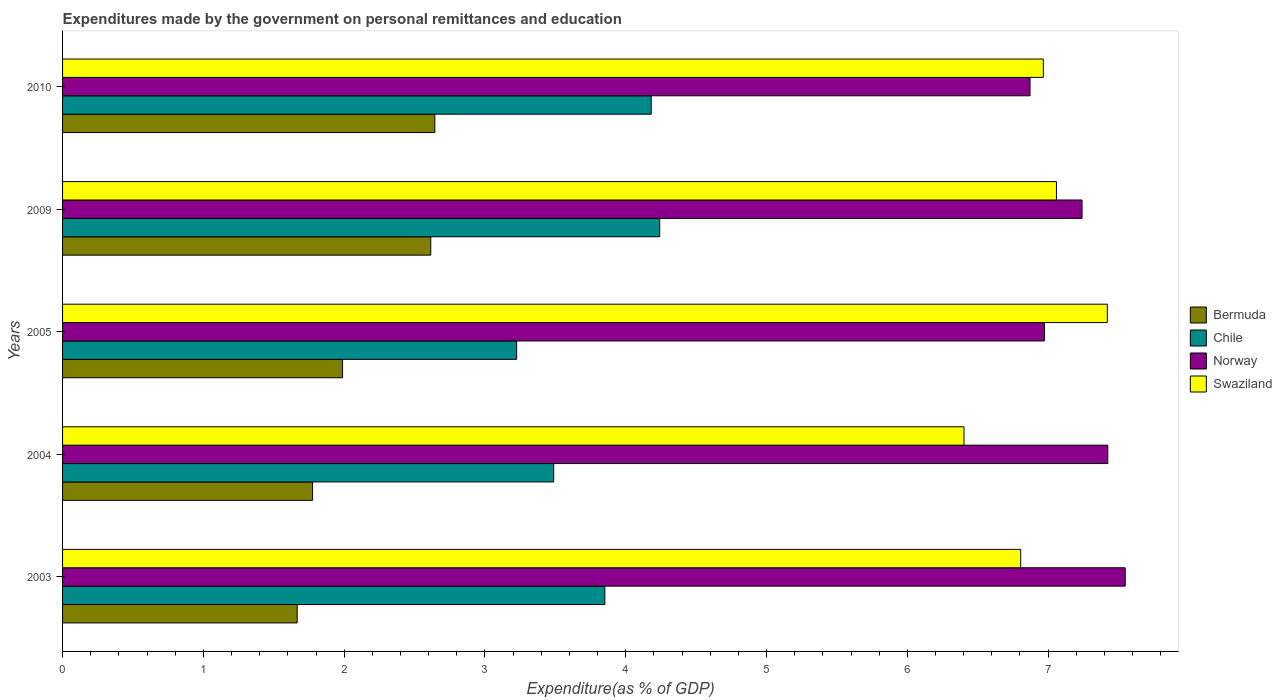How many different coloured bars are there?
Offer a terse response. 4. Are the number of bars on each tick of the Y-axis equal?
Give a very brief answer. Yes. What is the expenditures made by the government on personal remittances and education in Swaziland in 2004?
Your answer should be very brief. 6.4. Across all years, what is the maximum expenditures made by the government on personal remittances and education in Swaziland?
Ensure brevity in your answer.  7.42. Across all years, what is the minimum expenditures made by the government on personal remittances and education in Chile?
Provide a short and direct response. 3.23. In which year was the expenditures made by the government on personal remittances and education in Bermuda maximum?
Make the answer very short. 2010. What is the total expenditures made by the government on personal remittances and education in Norway in the graph?
Offer a terse response. 36.06. What is the difference between the expenditures made by the government on personal remittances and education in Bermuda in 2004 and that in 2005?
Give a very brief answer. -0.21. What is the difference between the expenditures made by the government on personal remittances and education in Swaziland in 2004 and the expenditures made by the government on personal remittances and education in Chile in 2003?
Provide a short and direct response. 2.55. What is the average expenditures made by the government on personal remittances and education in Swaziland per year?
Make the answer very short. 6.93. In the year 2005, what is the difference between the expenditures made by the government on personal remittances and education in Chile and expenditures made by the government on personal remittances and education in Swaziland?
Make the answer very short. -4.2. What is the ratio of the expenditures made by the government on personal remittances and education in Norway in 2004 to that in 2010?
Offer a terse response. 1.08. What is the difference between the highest and the second highest expenditures made by the government on personal remittances and education in Chile?
Keep it short and to the point. 0.06. What is the difference between the highest and the lowest expenditures made by the government on personal remittances and education in Norway?
Your answer should be very brief. 0.68. In how many years, is the expenditures made by the government on personal remittances and education in Chile greater than the average expenditures made by the government on personal remittances and education in Chile taken over all years?
Ensure brevity in your answer.  3. Is it the case that in every year, the sum of the expenditures made by the government on personal remittances and education in Norway and expenditures made by the government on personal remittances and education in Bermuda is greater than the sum of expenditures made by the government on personal remittances and education in Swaziland and expenditures made by the government on personal remittances and education in Chile?
Your response must be concise. No. What does the 4th bar from the top in 2009 represents?
Your response must be concise. Bermuda. Are all the bars in the graph horizontal?
Your answer should be compact. Yes. Are the values on the major ticks of X-axis written in scientific E-notation?
Provide a short and direct response. No. Does the graph contain any zero values?
Offer a terse response. No. How many legend labels are there?
Your response must be concise. 4. What is the title of the graph?
Give a very brief answer. Expenditures made by the government on personal remittances and education. Does "St. Martin (French part)" appear as one of the legend labels in the graph?
Your response must be concise. No. What is the label or title of the X-axis?
Make the answer very short. Expenditure(as % of GDP). What is the Expenditure(as % of GDP) in Bermuda in 2003?
Make the answer very short. 1.67. What is the Expenditure(as % of GDP) in Chile in 2003?
Ensure brevity in your answer.  3.85. What is the Expenditure(as % of GDP) of Norway in 2003?
Provide a short and direct response. 7.55. What is the Expenditure(as % of GDP) of Swaziland in 2003?
Ensure brevity in your answer.  6.81. What is the Expenditure(as % of GDP) of Bermuda in 2004?
Provide a succinct answer. 1.78. What is the Expenditure(as % of GDP) of Chile in 2004?
Give a very brief answer. 3.49. What is the Expenditure(as % of GDP) of Norway in 2004?
Give a very brief answer. 7.42. What is the Expenditure(as % of GDP) in Swaziland in 2004?
Keep it short and to the point. 6.4. What is the Expenditure(as % of GDP) of Bermuda in 2005?
Your answer should be compact. 1.99. What is the Expenditure(as % of GDP) of Chile in 2005?
Give a very brief answer. 3.23. What is the Expenditure(as % of GDP) in Norway in 2005?
Offer a very short reply. 6.97. What is the Expenditure(as % of GDP) of Swaziland in 2005?
Your answer should be compact. 7.42. What is the Expenditure(as % of GDP) in Bermuda in 2009?
Offer a very short reply. 2.62. What is the Expenditure(as % of GDP) in Chile in 2009?
Keep it short and to the point. 4.24. What is the Expenditure(as % of GDP) of Norway in 2009?
Your response must be concise. 7.24. What is the Expenditure(as % of GDP) in Swaziland in 2009?
Your response must be concise. 7.06. What is the Expenditure(as % of GDP) of Bermuda in 2010?
Ensure brevity in your answer.  2.64. What is the Expenditure(as % of GDP) of Chile in 2010?
Give a very brief answer. 4.18. What is the Expenditure(as % of GDP) of Norway in 2010?
Ensure brevity in your answer.  6.87. What is the Expenditure(as % of GDP) of Swaziland in 2010?
Provide a succinct answer. 6.97. Across all years, what is the maximum Expenditure(as % of GDP) in Bermuda?
Ensure brevity in your answer.  2.64. Across all years, what is the maximum Expenditure(as % of GDP) in Chile?
Keep it short and to the point. 4.24. Across all years, what is the maximum Expenditure(as % of GDP) in Norway?
Provide a short and direct response. 7.55. Across all years, what is the maximum Expenditure(as % of GDP) in Swaziland?
Your answer should be compact. 7.42. Across all years, what is the minimum Expenditure(as % of GDP) in Bermuda?
Your answer should be very brief. 1.67. Across all years, what is the minimum Expenditure(as % of GDP) in Chile?
Give a very brief answer. 3.23. Across all years, what is the minimum Expenditure(as % of GDP) in Norway?
Your answer should be compact. 6.87. Across all years, what is the minimum Expenditure(as % of GDP) in Swaziland?
Keep it short and to the point. 6.4. What is the total Expenditure(as % of GDP) of Bermuda in the graph?
Ensure brevity in your answer.  10.69. What is the total Expenditure(as % of GDP) of Chile in the graph?
Give a very brief answer. 18.99. What is the total Expenditure(as % of GDP) in Norway in the graph?
Your response must be concise. 36.06. What is the total Expenditure(as % of GDP) in Swaziland in the graph?
Make the answer very short. 34.65. What is the difference between the Expenditure(as % of GDP) of Bermuda in 2003 and that in 2004?
Offer a terse response. -0.11. What is the difference between the Expenditure(as % of GDP) in Chile in 2003 and that in 2004?
Offer a very short reply. 0.36. What is the difference between the Expenditure(as % of GDP) of Norway in 2003 and that in 2004?
Your answer should be very brief. 0.12. What is the difference between the Expenditure(as % of GDP) in Swaziland in 2003 and that in 2004?
Your answer should be compact. 0.4. What is the difference between the Expenditure(as % of GDP) in Bermuda in 2003 and that in 2005?
Make the answer very short. -0.32. What is the difference between the Expenditure(as % of GDP) in Chile in 2003 and that in 2005?
Offer a terse response. 0.63. What is the difference between the Expenditure(as % of GDP) in Norway in 2003 and that in 2005?
Make the answer very short. 0.57. What is the difference between the Expenditure(as % of GDP) of Swaziland in 2003 and that in 2005?
Provide a short and direct response. -0.62. What is the difference between the Expenditure(as % of GDP) of Bermuda in 2003 and that in 2009?
Provide a short and direct response. -0.95. What is the difference between the Expenditure(as % of GDP) in Chile in 2003 and that in 2009?
Your answer should be compact. -0.39. What is the difference between the Expenditure(as % of GDP) in Norway in 2003 and that in 2009?
Offer a terse response. 0.31. What is the difference between the Expenditure(as % of GDP) in Swaziland in 2003 and that in 2009?
Ensure brevity in your answer.  -0.25. What is the difference between the Expenditure(as % of GDP) of Bermuda in 2003 and that in 2010?
Give a very brief answer. -0.98. What is the difference between the Expenditure(as % of GDP) of Chile in 2003 and that in 2010?
Ensure brevity in your answer.  -0.33. What is the difference between the Expenditure(as % of GDP) of Norway in 2003 and that in 2010?
Keep it short and to the point. 0.68. What is the difference between the Expenditure(as % of GDP) of Swaziland in 2003 and that in 2010?
Provide a short and direct response. -0.16. What is the difference between the Expenditure(as % of GDP) of Bermuda in 2004 and that in 2005?
Give a very brief answer. -0.21. What is the difference between the Expenditure(as % of GDP) in Chile in 2004 and that in 2005?
Provide a succinct answer. 0.26. What is the difference between the Expenditure(as % of GDP) of Norway in 2004 and that in 2005?
Ensure brevity in your answer.  0.45. What is the difference between the Expenditure(as % of GDP) in Swaziland in 2004 and that in 2005?
Provide a succinct answer. -1.02. What is the difference between the Expenditure(as % of GDP) of Bermuda in 2004 and that in 2009?
Your response must be concise. -0.84. What is the difference between the Expenditure(as % of GDP) in Chile in 2004 and that in 2009?
Ensure brevity in your answer.  -0.75. What is the difference between the Expenditure(as % of GDP) in Norway in 2004 and that in 2009?
Provide a succinct answer. 0.18. What is the difference between the Expenditure(as % of GDP) in Swaziland in 2004 and that in 2009?
Give a very brief answer. -0.66. What is the difference between the Expenditure(as % of GDP) in Bermuda in 2004 and that in 2010?
Ensure brevity in your answer.  -0.87. What is the difference between the Expenditure(as % of GDP) of Chile in 2004 and that in 2010?
Make the answer very short. -0.69. What is the difference between the Expenditure(as % of GDP) of Norway in 2004 and that in 2010?
Keep it short and to the point. 0.55. What is the difference between the Expenditure(as % of GDP) of Swaziland in 2004 and that in 2010?
Keep it short and to the point. -0.56. What is the difference between the Expenditure(as % of GDP) of Bermuda in 2005 and that in 2009?
Your response must be concise. -0.63. What is the difference between the Expenditure(as % of GDP) of Chile in 2005 and that in 2009?
Provide a short and direct response. -1.02. What is the difference between the Expenditure(as % of GDP) of Norway in 2005 and that in 2009?
Provide a succinct answer. -0.27. What is the difference between the Expenditure(as % of GDP) of Swaziland in 2005 and that in 2009?
Your answer should be very brief. 0.36. What is the difference between the Expenditure(as % of GDP) in Bermuda in 2005 and that in 2010?
Offer a terse response. -0.66. What is the difference between the Expenditure(as % of GDP) of Chile in 2005 and that in 2010?
Provide a short and direct response. -0.96. What is the difference between the Expenditure(as % of GDP) in Norway in 2005 and that in 2010?
Your response must be concise. 0.1. What is the difference between the Expenditure(as % of GDP) in Swaziland in 2005 and that in 2010?
Your response must be concise. 0.45. What is the difference between the Expenditure(as % of GDP) in Bermuda in 2009 and that in 2010?
Provide a succinct answer. -0.03. What is the difference between the Expenditure(as % of GDP) in Chile in 2009 and that in 2010?
Offer a terse response. 0.06. What is the difference between the Expenditure(as % of GDP) in Norway in 2009 and that in 2010?
Keep it short and to the point. 0.37. What is the difference between the Expenditure(as % of GDP) of Swaziland in 2009 and that in 2010?
Make the answer very short. 0.09. What is the difference between the Expenditure(as % of GDP) in Bermuda in 2003 and the Expenditure(as % of GDP) in Chile in 2004?
Keep it short and to the point. -1.82. What is the difference between the Expenditure(as % of GDP) of Bermuda in 2003 and the Expenditure(as % of GDP) of Norway in 2004?
Your answer should be very brief. -5.76. What is the difference between the Expenditure(as % of GDP) in Bermuda in 2003 and the Expenditure(as % of GDP) in Swaziland in 2004?
Keep it short and to the point. -4.74. What is the difference between the Expenditure(as % of GDP) in Chile in 2003 and the Expenditure(as % of GDP) in Norway in 2004?
Give a very brief answer. -3.57. What is the difference between the Expenditure(as % of GDP) in Chile in 2003 and the Expenditure(as % of GDP) in Swaziland in 2004?
Offer a very short reply. -2.55. What is the difference between the Expenditure(as % of GDP) of Norway in 2003 and the Expenditure(as % of GDP) of Swaziland in 2004?
Your answer should be very brief. 1.14. What is the difference between the Expenditure(as % of GDP) in Bermuda in 2003 and the Expenditure(as % of GDP) in Chile in 2005?
Make the answer very short. -1.56. What is the difference between the Expenditure(as % of GDP) in Bermuda in 2003 and the Expenditure(as % of GDP) in Norway in 2005?
Your answer should be very brief. -5.31. What is the difference between the Expenditure(as % of GDP) of Bermuda in 2003 and the Expenditure(as % of GDP) of Swaziland in 2005?
Provide a short and direct response. -5.75. What is the difference between the Expenditure(as % of GDP) of Chile in 2003 and the Expenditure(as % of GDP) of Norway in 2005?
Provide a short and direct response. -3.12. What is the difference between the Expenditure(as % of GDP) in Chile in 2003 and the Expenditure(as % of GDP) in Swaziland in 2005?
Your response must be concise. -3.57. What is the difference between the Expenditure(as % of GDP) in Norway in 2003 and the Expenditure(as % of GDP) in Swaziland in 2005?
Offer a very short reply. 0.13. What is the difference between the Expenditure(as % of GDP) of Bermuda in 2003 and the Expenditure(as % of GDP) of Chile in 2009?
Keep it short and to the point. -2.58. What is the difference between the Expenditure(as % of GDP) of Bermuda in 2003 and the Expenditure(as % of GDP) of Norway in 2009?
Ensure brevity in your answer.  -5.57. What is the difference between the Expenditure(as % of GDP) in Bermuda in 2003 and the Expenditure(as % of GDP) in Swaziland in 2009?
Your answer should be compact. -5.39. What is the difference between the Expenditure(as % of GDP) of Chile in 2003 and the Expenditure(as % of GDP) of Norway in 2009?
Offer a very short reply. -3.39. What is the difference between the Expenditure(as % of GDP) in Chile in 2003 and the Expenditure(as % of GDP) in Swaziland in 2009?
Your answer should be compact. -3.21. What is the difference between the Expenditure(as % of GDP) of Norway in 2003 and the Expenditure(as % of GDP) of Swaziland in 2009?
Offer a terse response. 0.49. What is the difference between the Expenditure(as % of GDP) in Bermuda in 2003 and the Expenditure(as % of GDP) in Chile in 2010?
Your response must be concise. -2.51. What is the difference between the Expenditure(as % of GDP) of Bermuda in 2003 and the Expenditure(as % of GDP) of Norway in 2010?
Keep it short and to the point. -5.21. What is the difference between the Expenditure(as % of GDP) of Bermuda in 2003 and the Expenditure(as % of GDP) of Swaziland in 2010?
Provide a succinct answer. -5.3. What is the difference between the Expenditure(as % of GDP) of Chile in 2003 and the Expenditure(as % of GDP) of Norway in 2010?
Your answer should be very brief. -3.02. What is the difference between the Expenditure(as % of GDP) of Chile in 2003 and the Expenditure(as % of GDP) of Swaziland in 2010?
Provide a short and direct response. -3.11. What is the difference between the Expenditure(as % of GDP) in Norway in 2003 and the Expenditure(as % of GDP) in Swaziland in 2010?
Offer a very short reply. 0.58. What is the difference between the Expenditure(as % of GDP) of Bermuda in 2004 and the Expenditure(as % of GDP) of Chile in 2005?
Make the answer very short. -1.45. What is the difference between the Expenditure(as % of GDP) in Bermuda in 2004 and the Expenditure(as % of GDP) in Norway in 2005?
Provide a short and direct response. -5.2. What is the difference between the Expenditure(as % of GDP) in Bermuda in 2004 and the Expenditure(as % of GDP) in Swaziland in 2005?
Your answer should be very brief. -5.64. What is the difference between the Expenditure(as % of GDP) in Chile in 2004 and the Expenditure(as % of GDP) in Norway in 2005?
Provide a short and direct response. -3.49. What is the difference between the Expenditure(as % of GDP) of Chile in 2004 and the Expenditure(as % of GDP) of Swaziland in 2005?
Offer a terse response. -3.93. What is the difference between the Expenditure(as % of GDP) of Norway in 2004 and the Expenditure(as % of GDP) of Swaziland in 2005?
Offer a very short reply. 0. What is the difference between the Expenditure(as % of GDP) in Bermuda in 2004 and the Expenditure(as % of GDP) in Chile in 2009?
Your answer should be compact. -2.47. What is the difference between the Expenditure(as % of GDP) in Bermuda in 2004 and the Expenditure(as % of GDP) in Norway in 2009?
Your answer should be very brief. -5.47. What is the difference between the Expenditure(as % of GDP) in Bermuda in 2004 and the Expenditure(as % of GDP) in Swaziland in 2009?
Keep it short and to the point. -5.28. What is the difference between the Expenditure(as % of GDP) in Chile in 2004 and the Expenditure(as % of GDP) in Norway in 2009?
Your answer should be very brief. -3.75. What is the difference between the Expenditure(as % of GDP) in Chile in 2004 and the Expenditure(as % of GDP) in Swaziland in 2009?
Provide a short and direct response. -3.57. What is the difference between the Expenditure(as % of GDP) in Norway in 2004 and the Expenditure(as % of GDP) in Swaziland in 2009?
Provide a short and direct response. 0.36. What is the difference between the Expenditure(as % of GDP) of Bermuda in 2004 and the Expenditure(as % of GDP) of Chile in 2010?
Ensure brevity in your answer.  -2.4. What is the difference between the Expenditure(as % of GDP) in Bermuda in 2004 and the Expenditure(as % of GDP) in Norway in 2010?
Your response must be concise. -5.1. What is the difference between the Expenditure(as % of GDP) in Bermuda in 2004 and the Expenditure(as % of GDP) in Swaziland in 2010?
Your answer should be compact. -5.19. What is the difference between the Expenditure(as % of GDP) of Chile in 2004 and the Expenditure(as % of GDP) of Norway in 2010?
Provide a short and direct response. -3.38. What is the difference between the Expenditure(as % of GDP) in Chile in 2004 and the Expenditure(as % of GDP) in Swaziland in 2010?
Offer a terse response. -3.48. What is the difference between the Expenditure(as % of GDP) of Norway in 2004 and the Expenditure(as % of GDP) of Swaziland in 2010?
Provide a succinct answer. 0.46. What is the difference between the Expenditure(as % of GDP) of Bermuda in 2005 and the Expenditure(as % of GDP) of Chile in 2009?
Provide a short and direct response. -2.25. What is the difference between the Expenditure(as % of GDP) in Bermuda in 2005 and the Expenditure(as % of GDP) in Norway in 2009?
Ensure brevity in your answer.  -5.25. What is the difference between the Expenditure(as % of GDP) in Bermuda in 2005 and the Expenditure(as % of GDP) in Swaziland in 2009?
Your answer should be compact. -5.07. What is the difference between the Expenditure(as % of GDP) in Chile in 2005 and the Expenditure(as % of GDP) in Norway in 2009?
Your answer should be compact. -4.02. What is the difference between the Expenditure(as % of GDP) in Chile in 2005 and the Expenditure(as % of GDP) in Swaziland in 2009?
Your answer should be very brief. -3.83. What is the difference between the Expenditure(as % of GDP) in Norway in 2005 and the Expenditure(as % of GDP) in Swaziland in 2009?
Offer a very short reply. -0.09. What is the difference between the Expenditure(as % of GDP) of Bermuda in 2005 and the Expenditure(as % of GDP) of Chile in 2010?
Your answer should be compact. -2.19. What is the difference between the Expenditure(as % of GDP) of Bermuda in 2005 and the Expenditure(as % of GDP) of Norway in 2010?
Your answer should be compact. -4.88. What is the difference between the Expenditure(as % of GDP) of Bermuda in 2005 and the Expenditure(as % of GDP) of Swaziland in 2010?
Offer a terse response. -4.98. What is the difference between the Expenditure(as % of GDP) in Chile in 2005 and the Expenditure(as % of GDP) in Norway in 2010?
Provide a short and direct response. -3.65. What is the difference between the Expenditure(as % of GDP) in Chile in 2005 and the Expenditure(as % of GDP) in Swaziland in 2010?
Offer a terse response. -3.74. What is the difference between the Expenditure(as % of GDP) in Norway in 2005 and the Expenditure(as % of GDP) in Swaziland in 2010?
Provide a short and direct response. 0.01. What is the difference between the Expenditure(as % of GDP) in Bermuda in 2009 and the Expenditure(as % of GDP) in Chile in 2010?
Provide a succinct answer. -1.57. What is the difference between the Expenditure(as % of GDP) of Bermuda in 2009 and the Expenditure(as % of GDP) of Norway in 2010?
Make the answer very short. -4.26. What is the difference between the Expenditure(as % of GDP) of Bermuda in 2009 and the Expenditure(as % of GDP) of Swaziland in 2010?
Make the answer very short. -4.35. What is the difference between the Expenditure(as % of GDP) of Chile in 2009 and the Expenditure(as % of GDP) of Norway in 2010?
Keep it short and to the point. -2.63. What is the difference between the Expenditure(as % of GDP) in Chile in 2009 and the Expenditure(as % of GDP) in Swaziland in 2010?
Give a very brief answer. -2.72. What is the difference between the Expenditure(as % of GDP) in Norway in 2009 and the Expenditure(as % of GDP) in Swaziland in 2010?
Keep it short and to the point. 0.27. What is the average Expenditure(as % of GDP) in Bermuda per year?
Provide a succinct answer. 2.14. What is the average Expenditure(as % of GDP) of Chile per year?
Offer a terse response. 3.8. What is the average Expenditure(as % of GDP) in Norway per year?
Offer a very short reply. 7.21. What is the average Expenditure(as % of GDP) of Swaziland per year?
Provide a short and direct response. 6.93. In the year 2003, what is the difference between the Expenditure(as % of GDP) in Bermuda and Expenditure(as % of GDP) in Chile?
Offer a terse response. -2.19. In the year 2003, what is the difference between the Expenditure(as % of GDP) in Bermuda and Expenditure(as % of GDP) in Norway?
Give a very brief answer. -5.88. In the year 2003, what is the difference between the Expenditure(as % of GDP) of Bermuda and Expenditure(as % of GDP) of Swaziland?
Keep it short and to the point. -5.14. In the year 2003, what is the difference between the Expenditure(as % of GDP) of Chile and Expenditure(as % of GDP) of Norway?
Your answer should be very brief. -3.7. In the year 2003, what is the difference between the Expenditure(as % of GDP) of Chile and Expenditure(as % of GDP) of Swaziland?
Give a very brief answer. -2.95. In the year 2003, what is the difference between the Expenditure(as % of GDP) of Norway and Expenditure(as % of GDP) of Swaziland?
Provide a succinct answer. 0.74. In the year 2004, what is the difference between the Expenditure(as % of GDP) in Bermuda and Expenditure(as % of GDP) in Chile?
Provide a succinct answer. -1.71. In the year 2004, what is the difference between the Expenditure(as % of GDP) in Bermuda and Expenditure(as % of GDP) in Norway?
Give a very brief answer. -5.65. In the year 2004, what is the difference between the Expenditure(as % of GDP) of Bermuda and Expenditure(as % of GDP) of Swaziland?
Provide a succinct answer. -4.63. In the year 2004, what is the difference between the Expenditure(as % of GDP) in Chile and Expenditure(as % of GDP) in Norway?
Ensure brevity in your answer.  -3.94. In the year 2004, what is the difference between the Expenditure(as % of GDP) of Chile and Expenditure(as % of GDP) of Swaziland?
Offer a terse response. -2.91. In the year 2004, what is the difference between the Expenditure(as % of GDP) in Norway and Expenditure(as % of GDP) in Swaziland?
Provide a short and direct response. 1.02. In the year 2005, what is the difference between the Expenditure(as % of GDP) in Bermuda and Expenditure(as % of GDP) in Chile?
Your response must be concise. -1.24. In the year 2005, what is the difference between the Expenditure(as % of GDP) in Bermuda and Expenditure(as % of GDP) in Norway?
Keep it short and to the point. -4.99. In the year 2005, what is the difference between the Expenditure(as % of GDP) of Bermuda and Expenditure(as % of GDP) of Swaziland?
Keep it short and to the point. -5.43. In the year 2005, what is the difference between the Expenditure(as % of GDP) of Chile and Expenditure(as % of GDP) of Norway?
Provide a short and direct response. -3.75. In the year 2005, what is the difference between the Expenditure(as % of GDP) in Chile and Expenditure(as % of GDP) in Swaziland?
Offer a terse response. -4.2. In the year 2005, what is the difference between the Expenditure(as % of GDP) of Norway and Expenditure(as % of GDP) of Swaziland?
Give a very brief answer. -0.45. In the year 2009, what is the difference between the Expenditure(as % of GDP) of Bermuda and Expenditure(as % of GDP) of Chile?
Keep it short and to the point. -1.63. In the year 2009, what is the difference between the Expenditure(as % of GDP) of Bermuda and Expenditure(as % of GDP) of Norway?
Provide a succinct answer. -4.63. In the year 2009, what is the difference between the Expenditure(as % of GDP) in Bermuda and Expenditure(as % of GDP) in Swaziland?
Ensure brevity in your answer.  -4.44. In the year 2009, what is the difference between the Expenditure(as % of GDP) in Chile and Expenditure(as % of GDP) in Norway?
Your answer should be very brief. -3. In the year 2009, what is the difference between the Expenditure(as % of GDP) in Chile and Expenditure(as % of GDP) in Swaziland?
Your response must be concise. -2.82. In the year 2009, what is the difference between the Expenditure(as % of GDP) of Norway and Expenditure(as % of GDP) of Swaziland?
Ensure brevity in your answer.  0.18. In the year 2010, what is the difference between the Expenditure(as % of GDP) of Bermuda and Expenditure(as % of GDP) of Chile?
Offer a terse response. -1.54. In the year 2010, what is the difference between the Expenditure(as % of GDP) of Bermuda and Expenditure(as % of GDP) of Norway?
Keep it short and to the point. -4.23. In the year 2010, what is the difference between the Expenditure(as % of GDP) in Bermuda and Expenditure(as % of GDP) in Swaziland?
Make the answer very short. -4.32. In the year 2010, what is the difference between the Expenditure(as % of GDP) of Chile and Expenditure(as % of GDP) of Norway?
Provide a short and direct response. -2.69. In the year 2010, what is the difference between the Expenditure(as % of GDP) of Chile and Expenditure(as % of GDP) of Swaziland?
Make the answer very short. -2.79. In the year 2010, what is the difference between the Expenditure(as % of GDP) of Norway and Expenditure(as % of GDP) of Swaziland?
Provide a short and direct response. -0.09. What is the ratio of the Expenditure(as % of GDP) in Bermuda in 2003 to that in 2004?
Give a very brief answer. 0.94. What is the ratio of the Expenditure(as % of GDP) in Chile in 2003 to that in 2004?
Keep it short and to the point. 1.1. What is the ratio of the Expenditure(as % of GDP) of Norway in 2003 to that in 2004?
Your answer should be compact. 1.02. What is the ratio of the Expenditure(as % of GDP) of Swaziland in 2003 to that in 2004?
Your answer should be very brief. 1.06. What is the ratio of the Expenditure(as % of GDP) of Bermuda in 2003 to that in 2005?
Offer a terse response. 0.84. What is the ratio of the Expenditure(as % of GDP) of Chile in 2003 to that in 2005?
Ensure brevity in your answer.  1.19. What is the ratio of the Expenditure(as % of GDP) in Norway in 2003 to that in 2005?
Your answer should be very brief. 1.08. What is the ratio of the Expenditure(as % of GDP) in Swaziland in 2003 to that in 2005?
Your response must be concise. 0.92. What is the ratio of the Expenditure(as % of GDP) of Bermuda in 2003 to that in 2009?
Provide a succinct answer. 0.64. What is the ratio of the Expenditure(as % of GDP) of Chile in 2003 to that in 2009?
Keep it short and to the point. 0.91. What is the ratio of the Expenditure(as % of GDP) in Norway in 2003 to that in 2009?
Ensure brevity in your answer.  1.04. What is the ratio of the Expenditure(as % of GDP) in Bermuda in 2003 to that in 2010?
Your answer should be very brief. 0.63. What is the ratio of the Expenditure(as % of GDP) in Chile in 2003 to that in 2010?
Offer a very short reply. 0.92. What is the ratio of the Expenditure(as % of GDP) in Norway in 2003 to that in 2010?
Keep it short and to the point. 1.1. What is the ratio of the Expenditure(as % of GDP) of Swaziland in 2003 to that in 2010?
Your answer should be compact. 0.98. What is the ratio of the Expenditure(as % of GDP) in Bermuda in 2004 to that in 2005?
Your answer should be compact. 0.89. What is the ratio of the Expenditure(as % of GDP) in Chile in 2004 to that in 2005?
Offer a terse response. 1.08. What is the ratio of the Expenditure(as % of GDP) in Norway in 2004 to that in 2005?
Provide a succinct answer. 1.06. What is the ratio of the Expenditure(as % of GDP) in Swaziland in 2004 to that in 2005?
Make the answer very short. 0.86. What is the ratio of the Expenditure(as % of GDP) in Bermuda in 2004 to that in 2009?
Make the answer very short. 0.68. What is the ratio of the Expenditure(as % of GDP) of Chile in 2004 to that in 2009?
Provide a succinct answer. 0.82. What is the ratio of the Expenditure(as % of GDP) of Norway in 2004 to that in 2009?
Provide a succinct answer. 1.03. What is the ratio of the Expenditure(as % of GDP) of Swaziland in 2004 to that in 2009?
Provide a succinct answer. 0.91. What is the ratio of the Expenditure(as % of GDP) of Bermuda in 2004 to that in 2010?
Your answer should be compact. 0.67. What is the ratio of the Expenditure(as % of GDP) of Chile in 2004 to that in 2010?
Provide a succinct answer. 0.83. What is the ratio of the Expenditure(as % of GDP) of Norway in 2004 to that in 2010?
Provide a short and direct response. 1.08. What is the ratio of the Expenditure(as % of GDP) in Swaziland in 2004 to that in 2010?
Offer a very short reply. 0.92. What is the ratio of the Expenditure(as % of GDP) in Bermuda in 2005 to that in 2009?
Make the answer very short. 0.76. What is the ratio of the Expenditure(as % of GDP) in Chile in 2005 to that in 2009?
Your answer should be compact. 0.76. What is the ratio of the Expenditure(as % of GDP) of Norway in 2005 to that in 2009?
Give a very brief answer. 0.96. What is the ratio of the Expenditure(as % of GDP) of Swaziland in 2005 to that in 2009?
Give a very brief answer. 1.05. What is the ratio of the Expenditure(as % of GDP) in Bermuda in 2005 to that in 2010?
Offer a very short reply. 0.75. What is the ratio of the Expenditure(as % of GDP) of Chile in 2005 to that in 2010?
Provide a short and direct response. 0.77. What is the ratio of the Expenditure(as % of GDP) of Norway in 2005 to that in 2010?
Ensure brevity in your answer.  1.01. What is the ratio of the Expenditure(as % of GDP) in Swaziland in 2005 to that in 2010?
Offer a very short reply. 1.07. What is the ratio of the Expenditure(as % of GDP) of Chile in 2009 to that in 2010?
Ensure brevity in your answer.  1.01. What is the ratio of the Expenditure(as % of GDP) of Norway in 2009 to that in 2010?
Ensure brevity in your answer.  1.05. What is the ratio of the Expenditure(as % of GDP) of Swaziland in 2009 to that in 2010?
Give a very brief answer. 1.01. What is the difference between the highest and the second highest Expenditure(as % of GDP) in Bermuda?
Provide a succinct answer. 0.03. What is the difference between the highest and the second highest Expenditure(as % of GDP) of Chile?
Offer a very short reply. 0.06. What is the difference between the highest and the second highest Expenditure(as % of GDP) of Norway?
Your answer should be very brief. 0.12. What is the difference between the highest and the second highest Expenditure(as % of GDP) in Swaziland?
Ensure brevity in your answer.  0.36. What is the difference between the highest and the lowest Expenditure(as % of GDP) in Bermuda?
Offer a terse response. 0.98. What is the difference between the highest and the lowest Expenditure(as % of GDP) in Chile?
Offer a very short reply. 1.02. What is the difference between the highest and the lowest Expenditure(as % of GDP) in Norway?
Make the answer very short. 0.68. What is the difference between the highest and the lowest Expenditure(as % of GDP) of Swaziland?
Your answer should be compact. 1.02. 